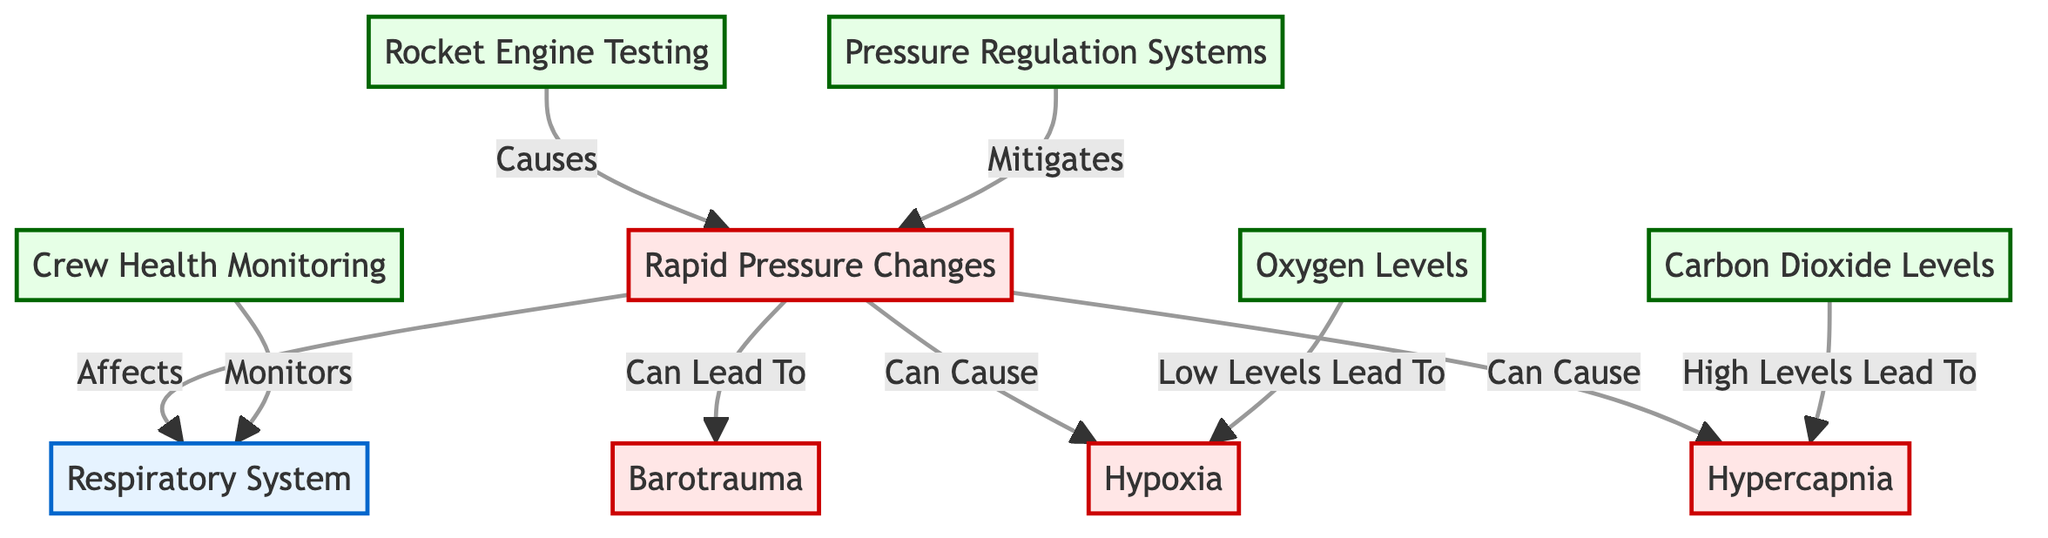What's the main system represented in the diagram? The diagram highlights the "Respiratory System" as the primary focus, indicated by the first node identified in the flowchart structure.
Answer: Respiratory System How many conditions are depicted in the diagram? By counting the relevant nodes, we identify four conditions labeled in the diagram: "Rapid Pressure Changes," "Barotrauma," "Hypoxia," and "Hypercapnia."
Answer: 4 What process is directly affected by rapid pressure changes? The diagram shows the arrow linking "Rapid Pressure Changes" to "Respiratory System," indicating that rapid pressure changes directly affect the respiratory system's function and health.
Answer: Respiratory System Which process monitors the health of the respiratory system? The diagram indicates "Crew Health Monitoring" as the process that specifically monitors the "Respiratory System," as denoted by the direct connection in the flowchart.
Answer: Crew Health Monitoring How does low oxygen levels affect crew health? The diagram connects "Low Levels" of "Oxygen" to "Hypoxia," indicating that when oxygen levels are low, it can lead to hypoxia, or inadequate oxygen supply, compromising health.
Answer: Hypoxia What can rapid pressure changes cause in the respiratory system? The diagram points out that rapid pressure changes can lead to multiple issues, specifically indicating "Barotrauma," "Hypoxia," and "Hypercapnia," which all impact the respiratory system adversely.
Answer: Barotrauma, Hypoxia, Hypercapnia Which process is involved in mitigating rapid pressure changes? According to the diagram, "Pressure Regulation Systems" are specifically designated as the process that mitigates the impacts of rapid pressure changes on the respiratory system.
Answer: Pressure Regulation Systems If carbon dioxide levels are high, what condition might result? The diagram indicates that high levels of carbon dioxide can cause "Hypercapnia," showing a direct correlation between carbon dioxide levels and this condition.
Answer: Hypercapnia What triggers rapid pressure changes according to the diagram? The diagram specifies "Rocket Engine Testing" as the triggering event that causes rapid pressure changes, establishing a causal relationship in the flow of the diagram.
Answer: Rocket Engine Testing 